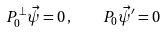Convert formula to latex. <formula><loc_0><loc_0><loc_500><loc_500>P _ { 0 } ^ { \perp } \vec { \psi } = 0 \, , \quad P _ { 0 } \vec { \psi } ^ { \prime } = 0</formula> 